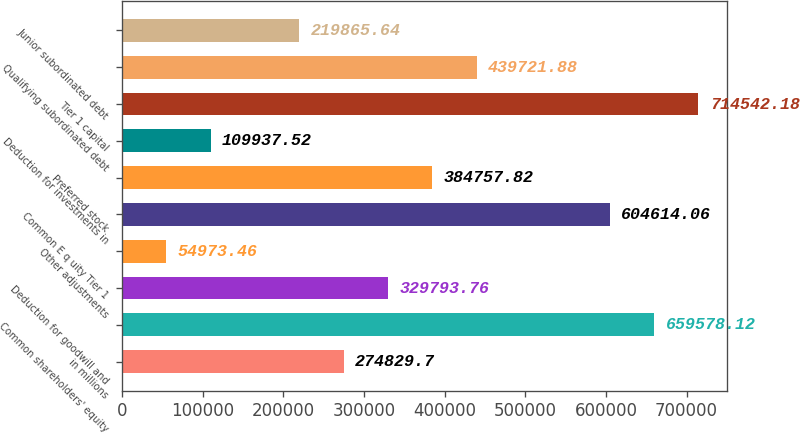Convert chart to OTSL. <chart><loc_0><loc_0><loc_500><loc_500><bar_chart><fcel>in millions<fcel>Common shareholders' equity<fcel>Deduction for goodwill and<fcel>Other adjustments<fcel>Common E q uity Tier 1<fcel>Preferred stock<fcel>Deduction for investments in<fcel>Tier 1 capital<fcel>Qualifying subordinated debt<fcel>Junior subordinated debt<nl><fcel>274830<fcel>659578<fcel>329794<fcel>54973.5<fcel>604614<fcel>384758<fcel>109938<fcel>714542<fcel>439722<fcel>219866<nl></chart> 